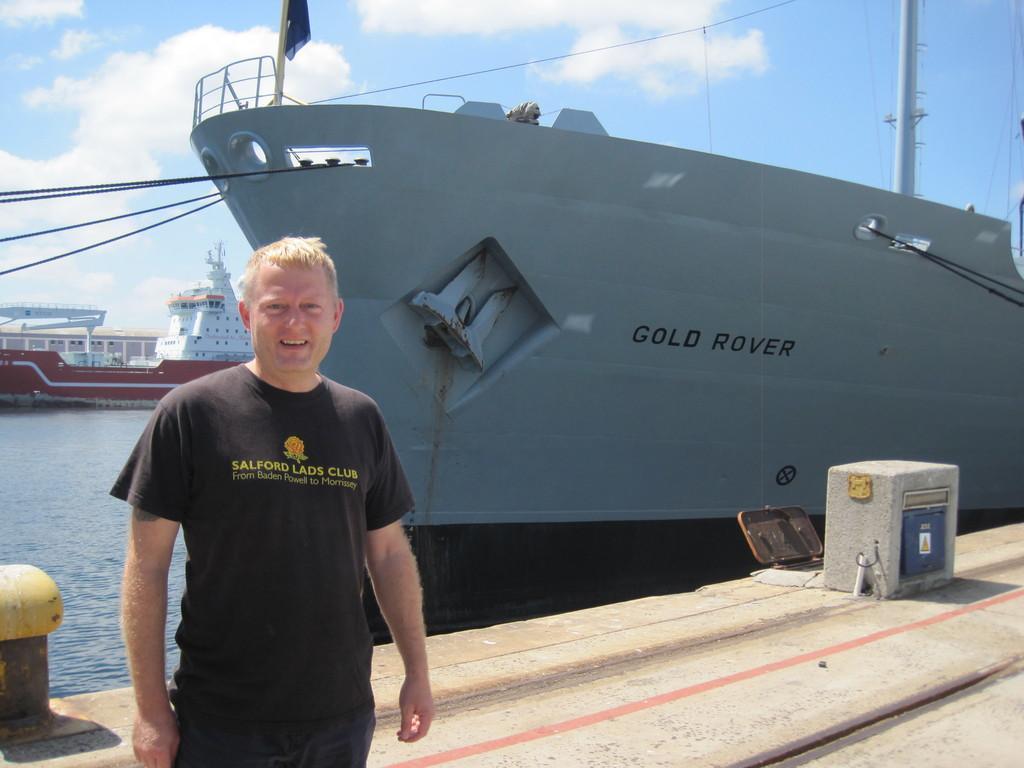Please provide a concise description of this image. In this image we can see a person standing on the ground, behind him we can see few ships on the water, there are some buildings and a flag, in the background we can see the sky with clouds. 